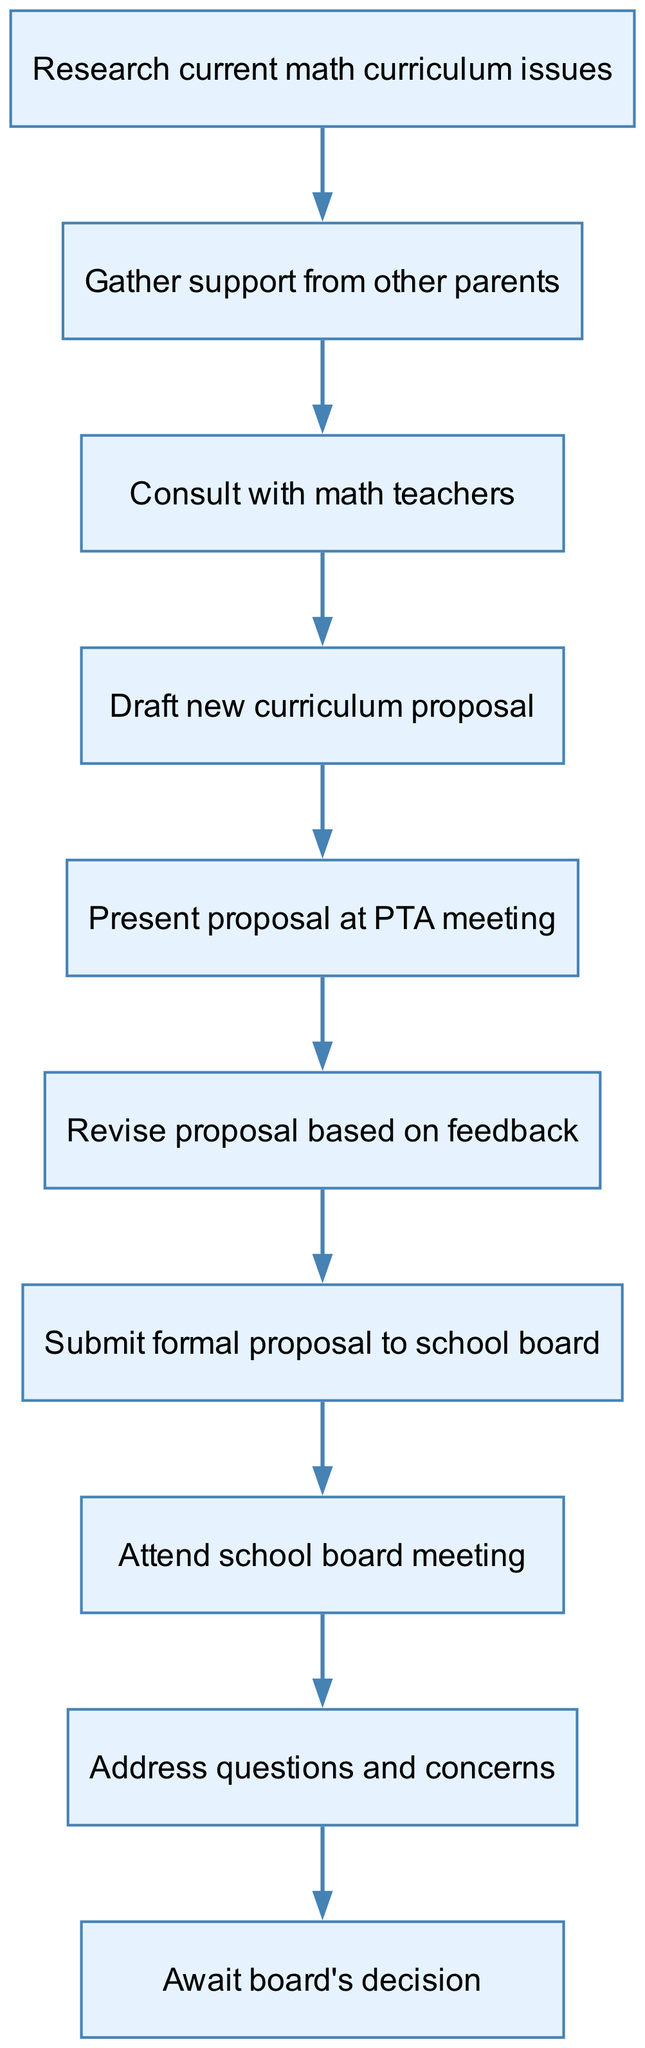What is the first step in the process? The diagram shows that the first step is to "Research current math curriculum issues". This is the first node in the flow chart, indicating it is where the process begins.
Answer: Research current math curriculum issues How many total steps are in this process? By counting all the nodes in the diagram, we find there are ten distinct steps listed. This includes each action to be taken throughout the proposal process.
Answer: Ten What step follows "Gather support from other parents"? In the flow chart, the next step after "Gather support from other parents" is "Consult with math teachers". This is determined by following the arrow from one node to the next.
Answer: Consult with math teachers What do you do after presenting the proposal at the PTA meeting? After presenting the proposal at the PTA meeting, the next action is to "Revise proposal based on feedback". This follows from the flow of the chart, indicating the need for adjustments based on responses received.
Answer: Revise proposal based on feedback What action must be taken after addressing questions and concerns? The action that follows "Address questions and concerns" is to "Await board's decision". This shows that after addressing any inquiries from the board, the next step is passive, waiting for their response.
Answer: Await board's decision Which step is immediately before drafting the new curriculum proposal? The step immediately before "Draft new curriculum proposal" is "Consult with math teachers". This means you first need to talk to teachers to get their input before drafting the proposal.
Answer: Consult with math teachers How many steps involve presenting or attending meetings? There are three steps involving meetings: "Present proposal at PTA meeting", "Attend school board meeting", and "Address questions and concerns". These steps concern interaction with stakeholders during the proposal process.
Answer: Three What is the last action in the process? The last action in the flow chart is "Await board's decision". This indicates the conclusion of the proposal process, as all actions have been completed prior to this step.
Answer: Await board's decision What is the relationship between gathering support and consulting with math teachers? The relationship is sequential; "Gather support from other parents" must be done before "Consult with math teachers". This implies that gaining parent backing is prioritized before engaging with educational professionals.
Answer: Sequential 